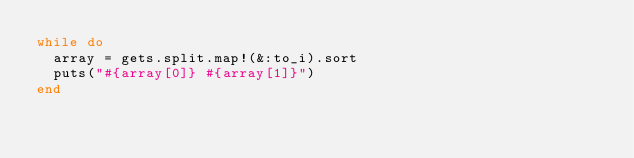Convert code to text. <code><loc_0><loc_0><loc_500><loc_500><_Ruby_>while do
  array = gets.split.map!(&:to_i).sort
  puts("#{array[0]} #{array[1]}")
end</code> 